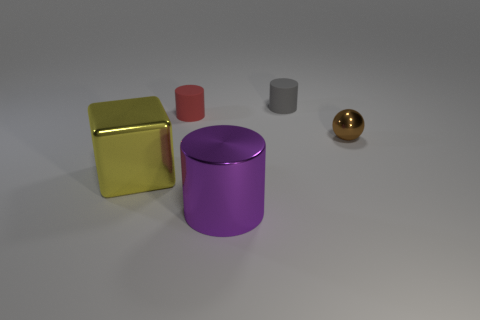What material is the tiny thing that is to the right of the tiny cylinder to the right of the purple cylinder?
Your answer should be very brief. Metal. Are there any gray cylinders to the left of the tiny brown shiny thing?
Keep it short and to the point. Yes. Are there an equal number of tiny shiny objects that are behind the big metallic cylinder and metallic cylinders?
Ensure brevity in your answer.  Yes. Are there any tiny rubber objects on the right side of the tiny rubber cylinder on the left side of the cylinder that is behind the red rubber object?
Your answer should be very brief. Yes. What is the material of the small brown sphere?
Your answer should be compact. Metal. What number of other objects are the same shape as the gray thing?
Keep it short and to the point. 2. Does the purple object have the same shape as the small gray matte object?
Provide a succinct answer. Yes. How many things are either small brown objects in front of the gray rubber thing or objects to the right of the cube?
Make the answer very short. 4. What number of things are either big metal cubes or tiny things?
Make the answer very short. 4. There is a cylinder that is in front of the small brown shiny sphere; what number of gray rubber cylinders are to the left of it?
Make the answer very short. 0. 